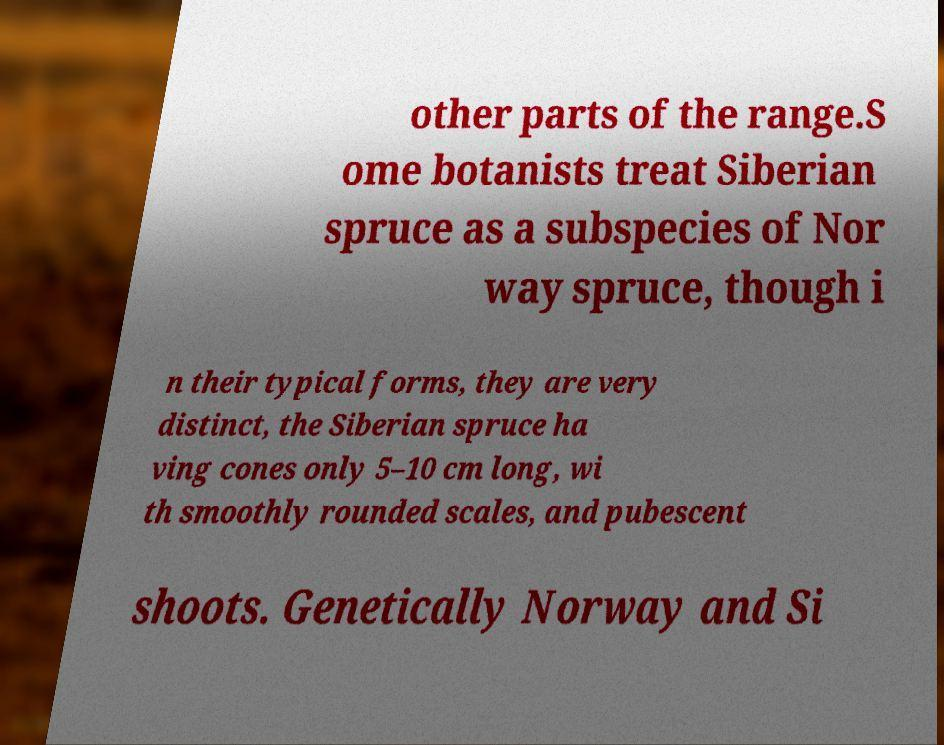I need the written content from this picture converted into text. Can you do that? other parts of the range.S ome botanists treat Siberian spruce as a subspecies of Nor way spruce, though i n their typical forms, they are very distinct, the Siberian spruce ha ving cones only 5–10 cm long, wi th smoothly rounded scales, and pubescent shoots. Genetically Norway and Si 